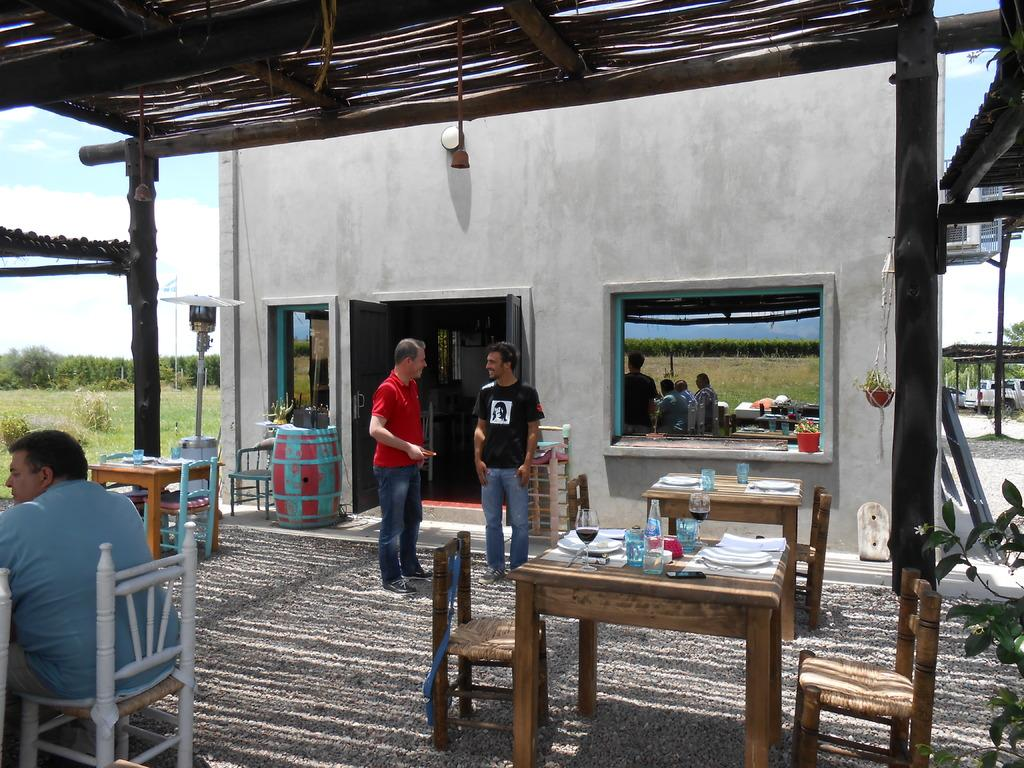What are the people in the image doing? There are people standing and sitting in the image. What is on the table in the image? There is a glass, a wine glass, a plate, and napkins on the table. How many glasses are on the table? There is one glass and one wine glass on the table. What type of basketball game is being played in the image? There is no basketball game present in the image. What type of harmony is being achieved by the people in the image? The image does not depict any specific harmony or interaction between the people; they are simply standing or sitting. 